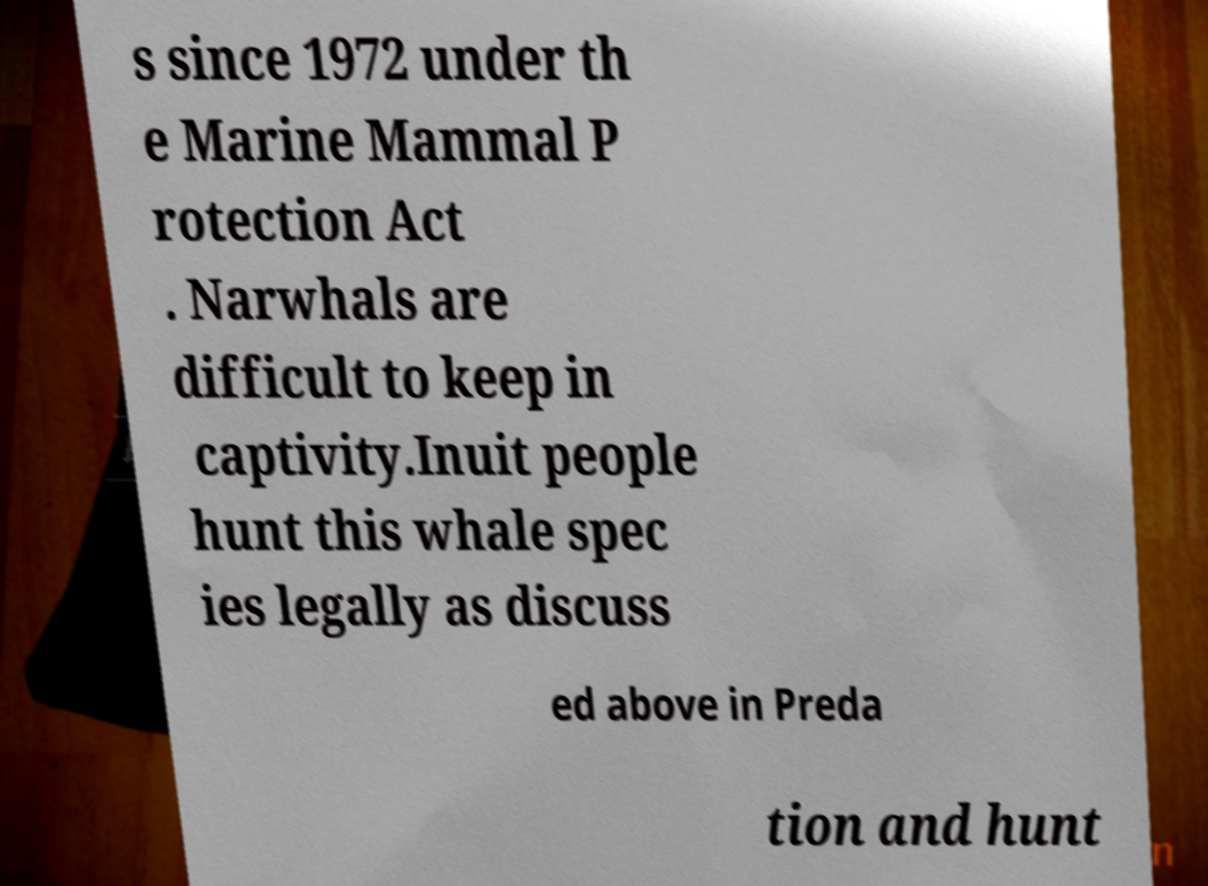There's text embedded in this image that I need extracted. Can you transcribe it verbatim? s since 1972 under th e Marine Mammal P rotection Act . Narwhals are difficult to keep in captivity.Inuit people hunt this whale spec ies legally as discuss ed above in Preda tion and hunt 